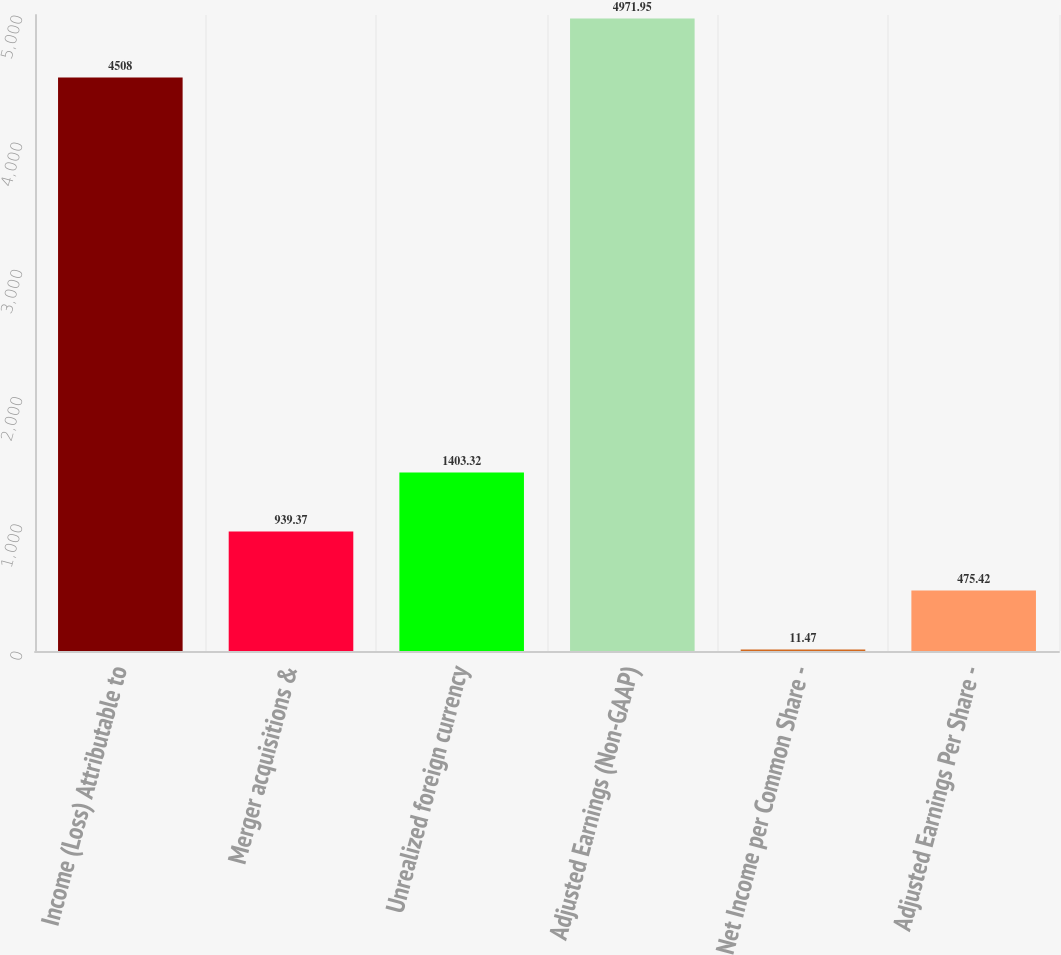Convert chart to OTSL. <chart><loc_0><loc_0><loc_500><loc_500><bar_chart><fcel>Income (Loss) Attributable to<fcel>Merger acquisitions &<fcel>Unrealized foreign currency<fcel>Adjusted Earnings (Non-GAAP)<fcel>Net Income per Common Share -<fcel>Adjusted Earnings Per Share -<nl><fcel>4508<fcel>939.37<fcel>1403.32<fcel>4971.95<fcel>11.47<fcel>475.42<nl></chart> 